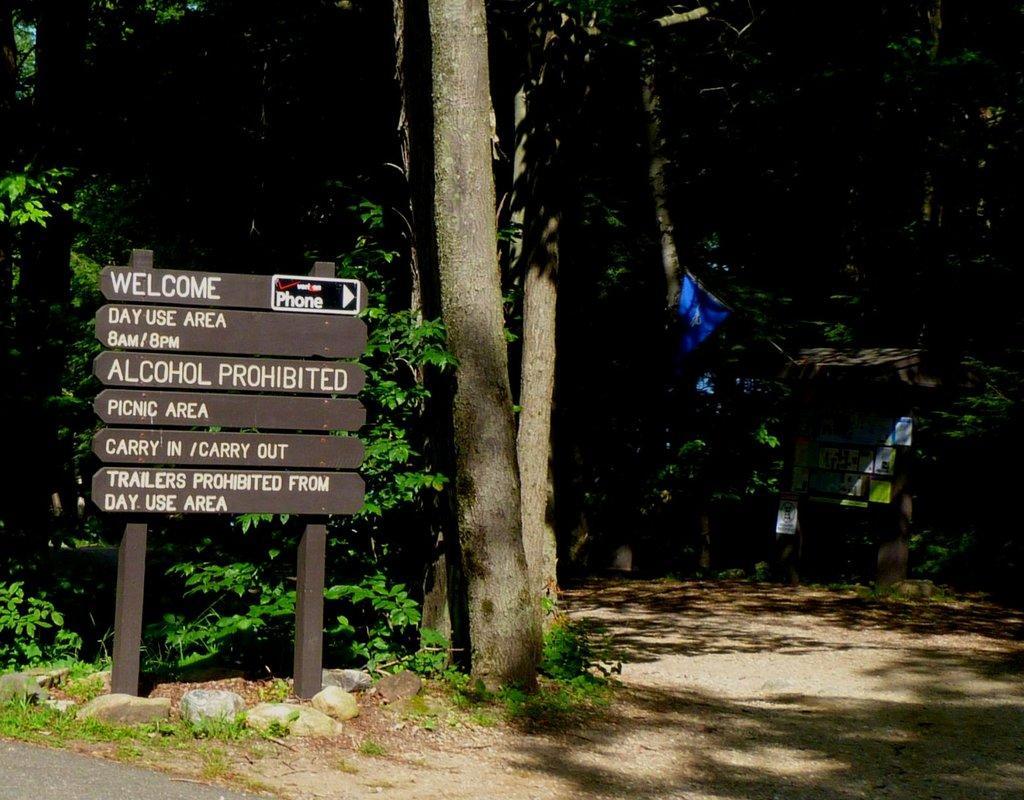Please provide a concise description of this image. This picture is clicked outside. On the left we can see the boards attached to the stand and we can see the text on the boards. In the background we can see the plants, trees and some other objects and we can see the rocks. 